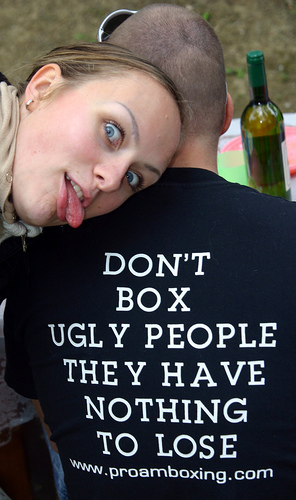<image>
Is there a sunglasses on the women? No. The sunglasses is not positioned on the women. They may be near each other, but the sunglasses is not supported by or resting on top of the women. 